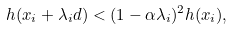<formula> <loc_0><loc_0><loc_500><loc_500>h ( x _ { i } + \lambda _ { i } d ) < ( 1 - \alpha \lambda _ { i } ) ^ { 2 } h ( x _ { i } ) ,</formula> 